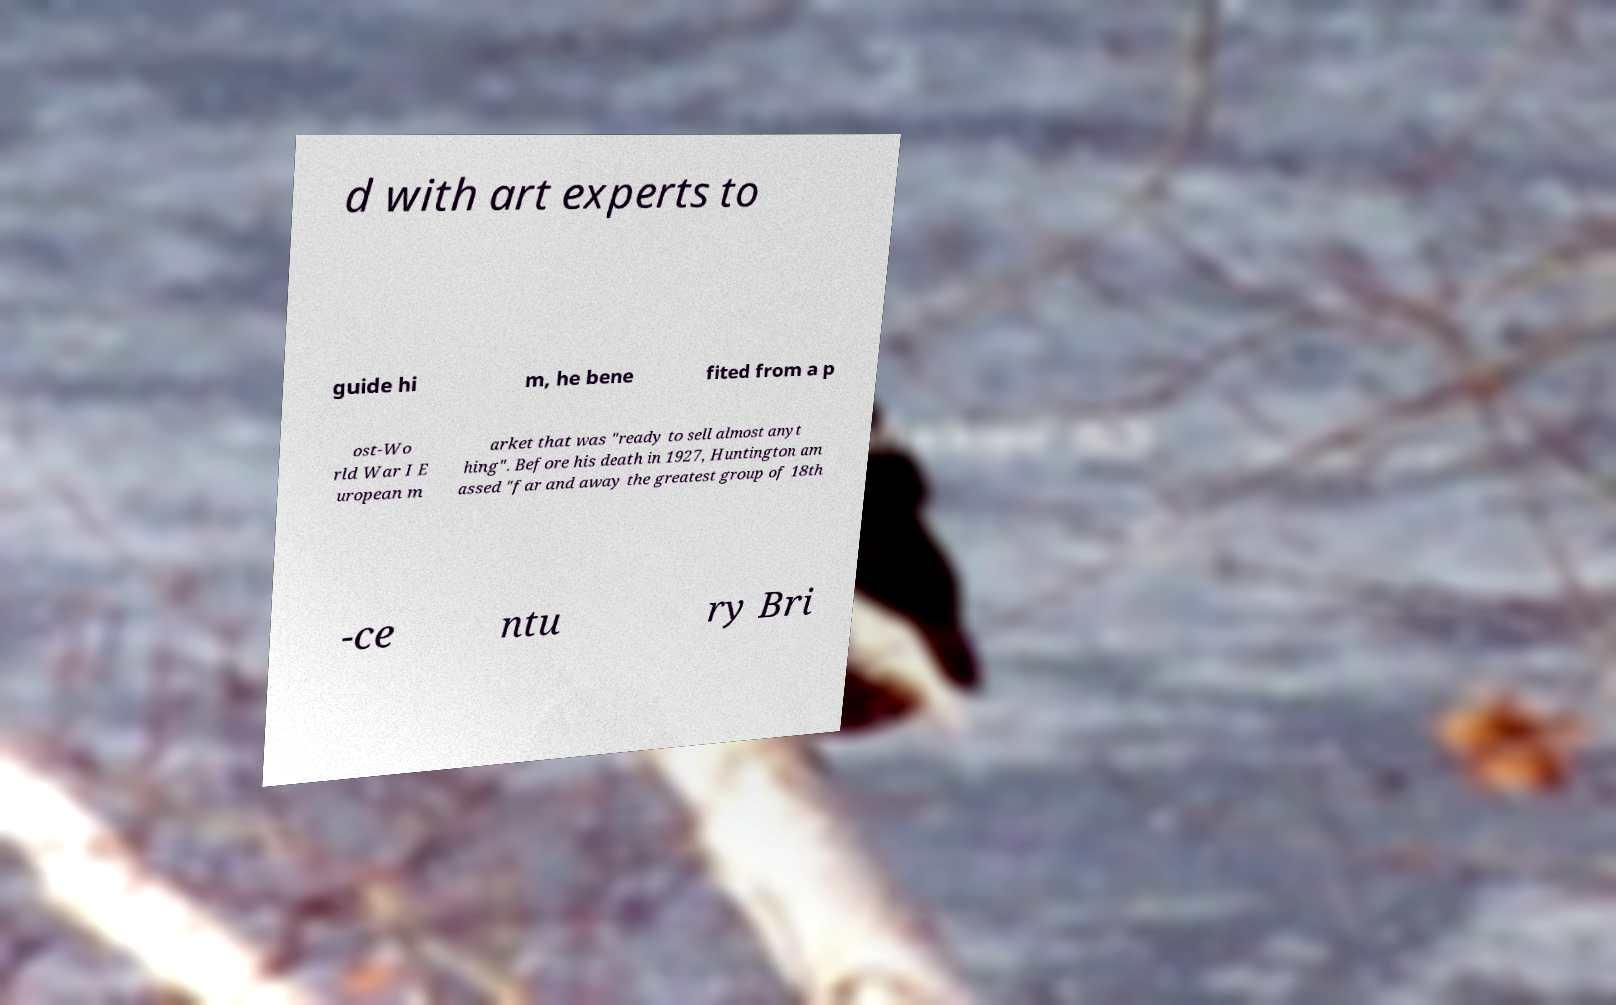Please read and relay the text visible in this image. What does it say? d with art experts to guide hi m, he bene fited from a p ost-Wo rld War I E uropean m arket that was "ready to sell almost anyt hing". Before his death in 1927, Huntington am assed "far and away the greatest group of 18th -ce ntu ry Bri 